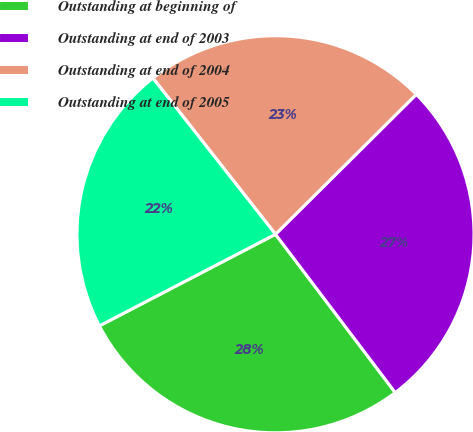Convert chart. <chart><loc_0><loc_0><loc_500><loc_500><pie_chart><fcel>Outstanding at beginning of<fcel>Outstanding at end of 2003<fcel>Outstanding at end of 2004<fcel>Outstanding at end of 2005<nl><fcel>27.67%<fcel>27.14%<fcel>23.14%<fcel>22.04%<nl></chart> 